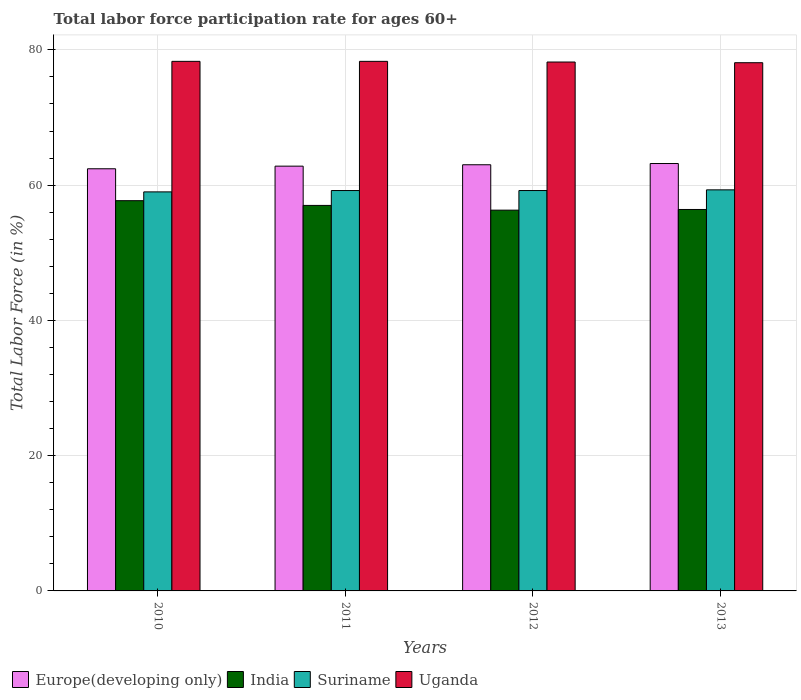How many different coloured bars are there?
Your answer should be compact. 4. How many groups of bars are there?
Make the answer very short. 4. Are the number of bars on each tick of the X-axis equal?
Keep it short and to the point. Yes. How many bars are there on the 2nd tick from the right?
Provide a short and direct response. 4. What is the label of the 3rd group of bars from the left?
Offer a terse response. 2012. In how many cases, is the number of bars for a given year not equal to the number of legend labels?
Ensure brevity in your answer.  0. What is the labor force participation rate in Uganda in 2012?
Ensure brevity in your answer.  78.2. Across all years, what is the maximum labor force participation rate in India?
Offer a terse response. 57.7. Across all years, what is the minimum labor force participation rate in Europe(developing only)?
Ensure brevity in your answer.  62.42. In which year was the labor force participation rate in Europe(developing only) maximum?
Make the answer very short. 2013. In which year was the labor force participation rate in Europe(developing only) minimum?
Your answer should be very brief. 2010. What is the total labor force participation rate in Europe(developing only) in the graph?
Provide a succinct answer. 251.43. What is the difference between the labor force participation rate in Suriname in 2011 and the labor force participation rate in India in 2012?
Keep it short and to the point. 2.9. What is the average labor force participation rate in Suriname per year?
Your answer should be compact. 59.18. In the year 2012, what is the difference between the labor force participation rate in Uganda and labor force participation rate in Europe(developing only)?
Keep it short and to the point. 15.19. In how many years, is the labor force participation rate in Europe(developing only) greater than 60 %?
Make the answer very short. 4. What is the ratio of the labor force participation rate in Suriname in 2011 to that in 2013?
Your answer should be very brief. 1. Is the labor force participation rate in Uganda in 2010 less than that in 2012?
Your answer should be very brief. No. Is the difference between the labor force participation rate in Uganda in 2010 and 2012 greater than the difference between the labor force participation rate in Europe(developing only) in 2010 and 2012?
Keep it short and to the point. Yes. What is the difference between the highest and the second highest labor force participation rate in Suriname?
Provide a succinct answer. 0.1. What is the difference between the highest and the lowest labor force participation rate in India?
Ensure brevity in your answer.  1.4. In how many years, is the labor force participation rate in Uganda greater than the average labor force participation rate in Uganda taken over all years?
Your answer should be compact. 2. Is it the case that in every year, the sum of the labor force participation rate in India and labor force participation rate in Europe(developing only) is greater than the sum of labor force participation rate in Suriname and labor force participation rate in Uganda?
Offer a very short reply. No. What does the 3rd bar from the left in 2011 represents?
Your answer should be compact. Suriname. What does the 1st bar from the right in 2010 represents?
Offer a very short reply. Uganda. Is it the case that in every year, the sum of the labor force participation rate in Europe(developing only) and labor force participation rate in India is greater than the labor force participation rate in Suriname?
Your answer should be very brief. Yes. What is the difference between two consecutive major ticks on the Y-axis?
Provide a short and direct response. 20. Are the values on the major ticks of Y-axis written in scientific E-notation?
Give a very brief answer. No. Does the graph contain any zero values?
Your answer should be compact. No. How many legend labels are there?
Make the answer very short. 4. What is the title of the graph?
Ensure brevity in your answer.  Total labor force participation rate for ages 60+. What is the Total Labor Force (in %) in Europe(developing only) in 2010?
Offer a very short reply. 62.42. What is the Total Labor Force (in %) of India in 2010?
Make the answer very short. 57.7. What is the Total Labor Force (in %) of Suriname in 2010?
Your answer should be compact. 59. What is the Total Labor Force (in %) in Uganda in 2010?
Offer a very short reply. 78.3. What is the Total Labor Force (in %) in Europe(developing only) in 2011?
Ensure brevity in your answer.  62.81. What is the Total Labor Force (in %) in India in 2011?
Ensure brevity in your answer.  57. What is the Total Labor Force (in %) of Suriname in 2011?
Offer a very short reply. 59.2. What is the Total Labor Force (in %) in Uganda in 2011?
Ensure brevity in your answer.  78.3. What is the Total Labor Force (in %) in Europe(developing only) in 2012?
Your response must be concise. 63.01. What is the Total Labor Force (in %) of India in 2012?
Offer a very short reply. 56.3. What is the Total Labor Force (in %) in Suriname in 2012?
Offer a terse response. 59.2. What is the Total Labor Force (in %) in Uganda in 2012?
Offer a very short reply. 78.2. What is the Total Labor Force (in %) of Europe(developing only) in 2013?
Ensure brevity in your answer.  63.19. What is the Total Labor Force (in %) in India in 2013?
Your response must be concise. 56.4. What is the Total Labor Force (in %) of Suriname in 2013?
Offer a terse response. 59.3. What is the Total Labor Force (in %) of Uganda in 2013?
Your answer should be very brief. 78.1. Across all years, what is the maximum Total Labor Force (in %) in Europe(developing only)?
Ensure brevity in your answer.  63.19. Across all years, what is the maximum Total Labor Force (in %) of India?
Offer a terse response. 57.7. Across all years, what is the maximum Total Labor Force (in %) of Suriname?
Provide a short and direct response. 59.3. Across all years, what is the maximum Total Labor Force (in %) in Uganda?
Ensure brevity in your answer.  78.3. Across all years, what is the minimum Total Labor Force (in %) in Europe(developing only)?
Make the answer very short. 62.42. Across all years, what is the minimum Total Labor Force (in %) of India?
Provide a succinct answer. 56.3. Across all years, what is the minimum Total Labor Force (in %) in Suriname?
Your response must be concise. 59. Across all years, what is the minimum Total Labor Force (in %) of Uganda?
Give a very brief answer. 78.1. What is the total Total Labor Force (in %) in Europe(developing only) in the graph?
Your response must be concise. 251.43. What is the total Total Labor Force (in %) in India in the graph?
Your response must be concise. 227.4. What is the total Total Labor Force (in %) of Suriname in the graph?
Ensure brevity in your answer.  236.7. What is the total Total Labor Force (in %) in Uganda in the graph?
Offer a very short reply. 312.9. What is the difference between the Total Labor Force (in %) in Europe(developing only) in 2010 and that in 2011?
Give a very brief answer. -0.39. What is the difference between the Total Labor Force (in %) of India in 2010 and that in 2011?
Give a very brief answer. 0.7. What is the difference between the Total Labor Force (in %) in Suriname in 2010 and that in 2011?
Give a very brief answer. -0.2. What is the difference between the Total Labor Force (in %) in Europe(developing only) in 2010 and that in 2012?
Your answer should be compact. -0.59. What is the difference between the Total Labor Force (in %) in Europe(developing only) in 2010 and that in 2013?
Provide a short and direct response. -0.78. What is the difference between the Total Labor Force (in %) of India in 2010 and that in 2013?
Offer a very short reply. 1.3. What is the difference between the Total Labor Force (in %) of Suriname in 2010 and that in 2013?
Ensure brevity in your answer.  -0.3. What is the difference between the Total Labor Force (in %) of Uganda in 2010 and that in 2013?
Provide a short and direct response. 0.2. What is the difference between the Total Labor Force (in %) in Europe(developing only) in 2011 and that in 2012?
Ensure brevity in your answer.  -0.21. What is the difference between the Total Labor Force (in %) of Uganda in 2011 and that in 2012?
Give a very brief answer. 0.1. What is the difference between the Total Labor Force (in %) of Europe(developing only) in 2011 and that in 2013?
Provide a succinct answer. -0.39. What is the difference between the Total Labor Force (in %) in India in 2011 and that in 2013?
Make the answer very short. 0.6. What is the difference between the Total Labor Force (in %) of Europe(developing only) in 2012 and that in 2013?
Make the answer very short. -0.18. What is the difference between the Total Labor Force (in %) in Suriname in 2012 and that in 2013?
Make the answer very short. -0.1. What is the difference between the Total Labor Force (in %) in Uganda in 2012 and that in 2013?
Give a very brief answer. 0.1. What is the difference between the Total Labor Force (in %) of Europe(developing only) in 2010 and the Total Labor Force (in %) of India in 2011?
Your answer should be compact. 5.42. What is the difference between the Total Labor Force (in %) in Europe(developing only) in 2010 and the Total Labor Force (in %) in Suriname in 2011?
Your answer should be very brief. 3.22. What is the difference between the Total Labor Force (in %) in Europe(developing only) in 2010 and the Total Labor Force (in %) in Uganda in 2011?
Your response must be concise. -15.88. What is the difference between the Total Labor Force (in %) of India in 2010 and the Total Labor Force (in %) of Uganda in 2011?
Make the answer very short. -20.6. What is the difference between the Total Labor Force (in %) in Suriname in 2010 and the Total Labor Force (in %) in Uganda in 2011?
Your answer should be very brief. -19.3. What is the difference between the Total Labor Force (in %) of Europe(developing only) in 2010 and the Total Labor Force (in %) of India in 2012?
Keep it short and to the point. 6.12. What is the difference between the Total Labor Force (in %) of Europe(developing only) in 2010 and the Total Labor Force (in %) of Suriname in 2012?
Your answer should be compact. 3.22. What is the difference between the Total Labor Force (in %) in Europe(developing only) in 2010 and the Total Labor Force (in %) in Uganda in 2012?
Keep it short and to the point. -15.78. What is the difference between the Total Labor Force (in %) of India in 2010 and the Total Labor Force (in %) of Suriname in 2012?
Offer a very short reply. -1.5. What is the difference between the Total Labor Force (in %) of India in 2010 and the Total Labor Force (in %) of Uganda in 2012?
Give a very brief answer. -20.5. What is the difference between the Total Labor Force (in %) in Suriname in 2010 and the Total Labor Force (in %) in Uganda in 2012?
Offer a very short reply. -19.2. What is the difference between the Total Labor Force (in %) of Europe(developing only) in 2010 and the Total Labor Force (in %) of India in 2013?
Your answer should be very brief. 6.02. What is the difference between the Total Labor Force (in %) of Europe(developing only) in 2010 and the Total Labor Force (in %) of Suriname in 2013?
Provide a short and direct response. 3.12. What is the difference between the Total Labor Force (in %) in Europe(developing only) in 2010 and the Total Labor Force (in %) in Uganda in 2013?
Offer a very short reply. -15.68. What is the difference between the Total Labor Force (in %) of India in 2010 and the Total Labor Force (in %) of Suriname in 2013?
Keep it short and to the point. -1.6. What is the difference between the Total Labor Force (in %) of India in 2010 and the Total Labor Force (in %) of Uganda in 2013?
Provide a succinct answer. -20.4. What is the difference between the Total Labor Force (in %) in Suriname in 2010 and the Total Labor Force (in %) in Uganda in 2013?
Offer a terse response. -19.1. What is the difference between the Total Labor Force (in %) in Europe(developing only) in 2011 and the Total Labor Force (in %) in India in 2012?
Offer a terse response. 6.51. What is the difference between the Total Labor Force (in %) in Europe(developing only) in 2011 and the Total Labor Force (in %) in Suriname in 2012?
Provide a short and direct response. 3.61. What is the difference between the Total Labor Force (in %) in Europe(developing only) in 2011 and the Total Labor Force (in %) in Uganda in 2012?
Offer a terse response. -15.39. What is the difference between the Total Labor Force (in %) of India in 2011 and the Total Labor Force (in %) of Suriname in 2012?
Make the answer very short. -2.2. What is the difference between the Total Labor Force (in %) of India in 2011 and the Total Labor Force (in %) of Uganda in 2012?
Provide a short and direct response. -21.2. What is the difference between the Total Labor Force (in %) in Europe(developing only) in 2011 and the Total Labor Force (in %) in India in 2013?
Offer a terse response. 6.41. What is the difference between the Total Labor Force (in %) in Europe(developing only) in 2011 and the Total Labor Force (in %) in Suriname in 2013?
Ensure brevity in your answer.  3.51. What is the difference between the Total Labor Force (in %) of Europe(developing only) in 2011 and the Total Labor Force (in %) of Uganda in 2013?
Provide a short and direct response. -15.29. What is the difference between the Total Labor Force (in %) in India in 2011 and the Total Labor Force (in %) in Uganda in 2013?
Your response must be concise. -21.1. What is the difference between the Total Labor Force (in %) of Suriname in 2011 and the Total Labor Force (in %) of Uganda in 2013?
Provide a succinct answer. -18.9. What is the difference between the Total Labor Force (in %) in Europe(developing only) in 2012 and the Total Labor Force (in %) in India in 2013?
Provide a short and direct response. 6.61. What is the difference between the Total Labor Force (in %) of Europe(developing only) in 2012 and the Total Labor Force (in %) of Suriname in 2013?
Provide a succinct answer. 3.71. What is the difference between the Total Labor Force (in %) of Europe(developing only) in 2012 and the Total Labor Force (in %) of Uganda in 2013?
Give a very brief answer. -15.09. What is the difference between the Total Labor Force (in %) in India in 2012 and the Total Labor Force (in %) in Suriname in 2013?
Your answer should be very brief. -3. What is the difference between the Total Labor Force (in %) in India in 2012 and the Total Labor Force (in %) in Uganda in 2013?
Make the answer very short. -21.8. What is the difference between the Total Labor Force (in %) of Suriname in 2012 and the Total Labor Force (in %) of Uganda in 2013?
Give a very brief answer. -18.9. What is the average Total Labor Force (in %) in Europe(developing only) per year?
Your answer should be very brief. 62.86. What is the average Total Labor Force (in %) in India per year?
Provide a succinct answer. 56.85. What is the average Total Labor Force (in %) of Suriname per year?
Provide a short and direct response. 59.17. What is the average Total Labor Force (in %) in Uganda per year?
Provide a short and direct response. 78.22. In the year 2010, what is the difference between the Total Labor Force (in %) in Europe(developing only) and Total Labor Force (in %) in India?
Your answer should be compact. 4.72. In the year 2010, what is the difference between the Total Labor Force (in %) of Europe(developing only) and Total Labor Force (in %) of Suriname?
Ensure brevity in your answer.  3.42. In the year 2010, what is the difference between the Total Labor Force (in %) in Europe(developing only) and Total Labor Force (in %) in Uganda?
Ensure brevity in your answer.  -15.88. In the year 2010, what is the difference between the Total Labor Force (in %) in India and Total Labor Force (in %) in Uganda?
Offer a terse response. -20.6. In the year 2010, what is the difference between the Total Labor Force (in %) in Suriname and Total Labor Force (in %) in Uganda?
Offer a terse response. -19.3. In the year 2011, what is the difference between the Total Labor Force (in %) of Europe(developing only) and Total Labor Force (in %) of India?
Your answer should be compact. 5.81. In the year 2011, what is the difference between the Total Labor Force (in %) in Europe(developing only) and Total Labor Force (in %) in Suriname?
Provide a succinct answer. 3.61. In the year 2011, what is the difference between the Total Labor Force (in %) in Europe(developing only) and Total Labor Force (in %) in Uganda?
Provide a succinct answer. -15.49. In the year 2011, what is the difference between the Total Labor Force (in %) in India and Total Labor Force (in %) in Uganda?
Provide a short and direct response. -21.3. In the year 2011, what is the difference between the Total Labor Force (in %) of Suriname and Total Labor Force (in %) of Uganda?
Provide a short and direct response. -19.1. In the year 2012, what is the difference between the Total Labor Force (in %) of Europe(developing only) and Total Labor Force (in %) of India?
Give a very brief answer. 6.71. In the year 2012, what is the difference between the Total Labor Force (in %) of Europe(developing only) and Total Labor Force (in %) of Suriname?
Offer a very short reply. 3.81. In the year 2012, what is the difference between the Total Labor Force (in %) in Europe(developing only) and Total Labor Force (in %) in Uganda?
Your answer should be compact. -15.19. In the year 2012, what is the difference between the Total Labor Force (in %) in India and Total Labor Force (in %) in Suriname?
Make the answer very short. -2.9. In the year 2012, what is the difference between the Total Labor Force (in %) of India and Total Labor Force (in %) of Uganda?
Make the answer very short. -21.9. In the year 2013, what is the difference between the Total Labor Force (in %) in Europe(developing only) and Total Labor Force (in %) in India?
Provide a short and direct response. 6.79. In the year 2013, what is the difference between the Total Labor Force (in %) in Europe(developing only) and Total Labor Force (in %) in Suriname?
Provide a succinct answer. 3.89. In the year 2013, what is the difference between the Total Labor Force (in %) in Europe(developing only) and Total Labor Force (in %) in Uganda?
Offer a terse response. -14.91. In the year 2013, what is the difference between the Total Labor Force (in %) in India and Total Labor Force (in %) in Uganda?
Offer a terse response. -21.7. In the year 2013, what is the difference between the Total Labor Force (in %) in Suriname and Total Labor Force (in %) in Uganda?
Your response must be concise. -18.8. What is the ratio of the Total Labor Force (in %) in Europe(developing only) in 2010 to that in 2011?
Give a very brief answer. 0.99. What is the ratio of the Total Labor Force (in %) of India in 2010 to that in 2011?
Offer a terse response. 1.01. What is the ratio of the Total Labor Force (in %) of Europe(developing only) in 2010 to that in 2012?
Offer a very short reply. 0.99. What is the ratio of the Total Labor Force (in %) in India in 2010 to that in 2012?
Ensure brevity in your answer.  1.02. What is the ratio of the Total Labor Force (in %) in Suriname in 2010 to that in 2012?
Provide a succinct answer. 1. What is the ratio of the Total Labor Force (in %) in Uganda in 2010 to that in 2013?
Your response must be concise. 1. What is the ratio of the Total Labor Force (in %) of India in 2011 to that in 2012?
Keep it short and to the point. 1.01. What is the ratio of the Total Labor Force (in %) in Suriname in 2011 to that in 2012?
Offer a terse response. 1. What is the ratio of the Total Labor Force (in %) in Europe(developing only) in 2011 to that in 2013?
Keep it short and to the point. 0.99. What is the ratio of the Total Labor Force (in %) of India in 2011 to that in 2013?
Give a very brief answer. 1.01. What is the ratio of the Total Labor Force (in %) in Suriname in 2011 to that in 2013?
Keep it short and to the point. 1. What is the ratio of the Total Labor Force (in %) in India in 2012 to that in 2013?
Provide a short and direct response. 1. What is the difference between the highest and the second highest Total Labor Force (in %) of Europe(developing only)?
Offer a terse response. 0.18. What is the difference between the highest and the lowest Total Labor Force (in %) of Europe(developing only)?
Your answer should be very brief. 0.78. What is the difference between the highest and the lowest Total Labor Force (in %) in Suriname?
Ensure brevity in your answer.  0.3. What is the difference between the highest and the lowest Total Labor Force (in %) in Uganda?
Your answer should be very brief. 0.2. 